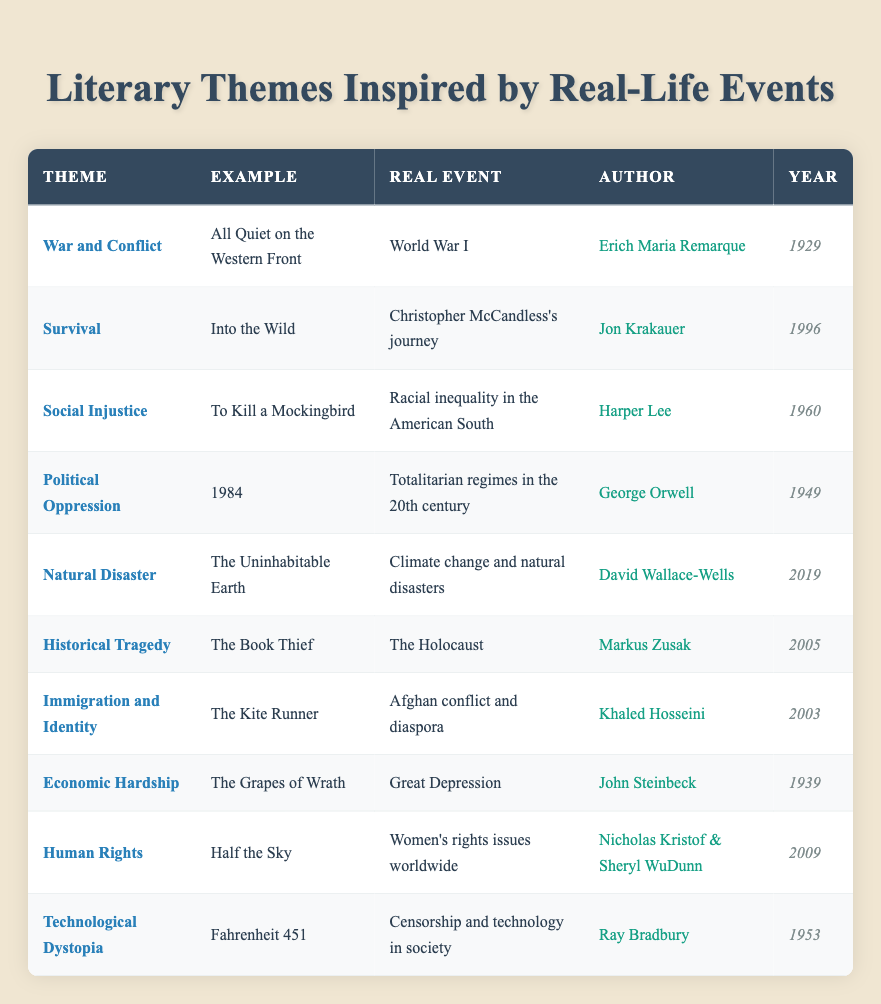What is the theme of "The Grapes of Wrath"? The table indicates that the example "The Grapes of Wrath" is categorized under the theme of "Economic Hardship."
Answer: Economic Hardship Who is the author of "1984"? By looking at the row for "1984," we can see that the author listed is George Orwell.
Answer: George Orwell How many books were published in the 2000s? The table lists three books published in the 2000s: "The Kite Runner" (2003), "The Book Thief" (2005), and "Half the Sky" (2009). Thus, the count is three.
Answer: 3 Did "Into the Wild" address a real-life event? Yes, according to the table, "Into the Wild" is based on Christopher McCandless's journey, which is a real-life event.
Answer: Yes What is the earliest publication year in the table? By reviewing the publication years listed, the earliest is 1929 for "All Quiet on the Western Front."
Answer: 1929 Which theme has the most recent publication year? The most recent publication in the table is "The Uninhabitable Earth," released in 2019. Therefore, the theme is "Natural Disaster."
Answer: Natural Disaster How many themes feature authors whose last names begin with 'K'? The table contains two entries with authors whose last names start with 'K': "Into the Wild" (Jon Krakauer) and "The Kite Runner" (Khaled Hosseini), leading to a total of two.
Answer: 2 What are the examples for the themes of "Survival" and "Political Oppression"? The theme "Survival" corresponds to "Into the Wild," while "Political Oppression" is represented by "1984."
Answer: Into the Wild, 1984 Which author wrote a book related to the Holocaust? The table specifies that Markus Zusak wrote "The Book Thief," which relates to the Holocaust.
Answer: Markus Zusak 